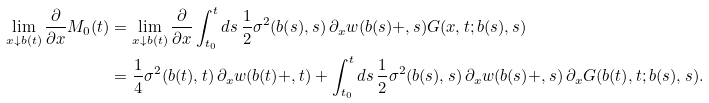<formula> <loc_0><loc_0><loc_500><loc_500>\lim _ { x \downarrow b ( t ) } \frac { \partial } { \partial x } M _ { 0 } ( t ) & = \lim _ { x \downarrow b ( t ) } \frac { \partial } { \partial x } \int _ { t _ { 0 } } ^ { t } d s \, \frac { 1 } { 2 } \sigma ^ { 2 } ( b ( s ) , s ) \, \partial _ { x } w ( b ( s ) + , s ) G ( x , t ; b ( s ) , s ) \\ & = \frac { 1 } { 4 } \sigma ^ { 2 } ( b ( t ) , t ) \, \partial _ { x } w ( b ( t ) + , t ) + \int ^ { t } _ { t _ { 0 } } d s \, \frac { 1 } { 2 } \sigma ^ { 2 } ( b ( s ) , s ) \, \partial _ { x } w ( b ( s ) + , s ) \, \partial _ { x } G ( b ( t ) , t ; b ( s ) , s ) .</formula> 